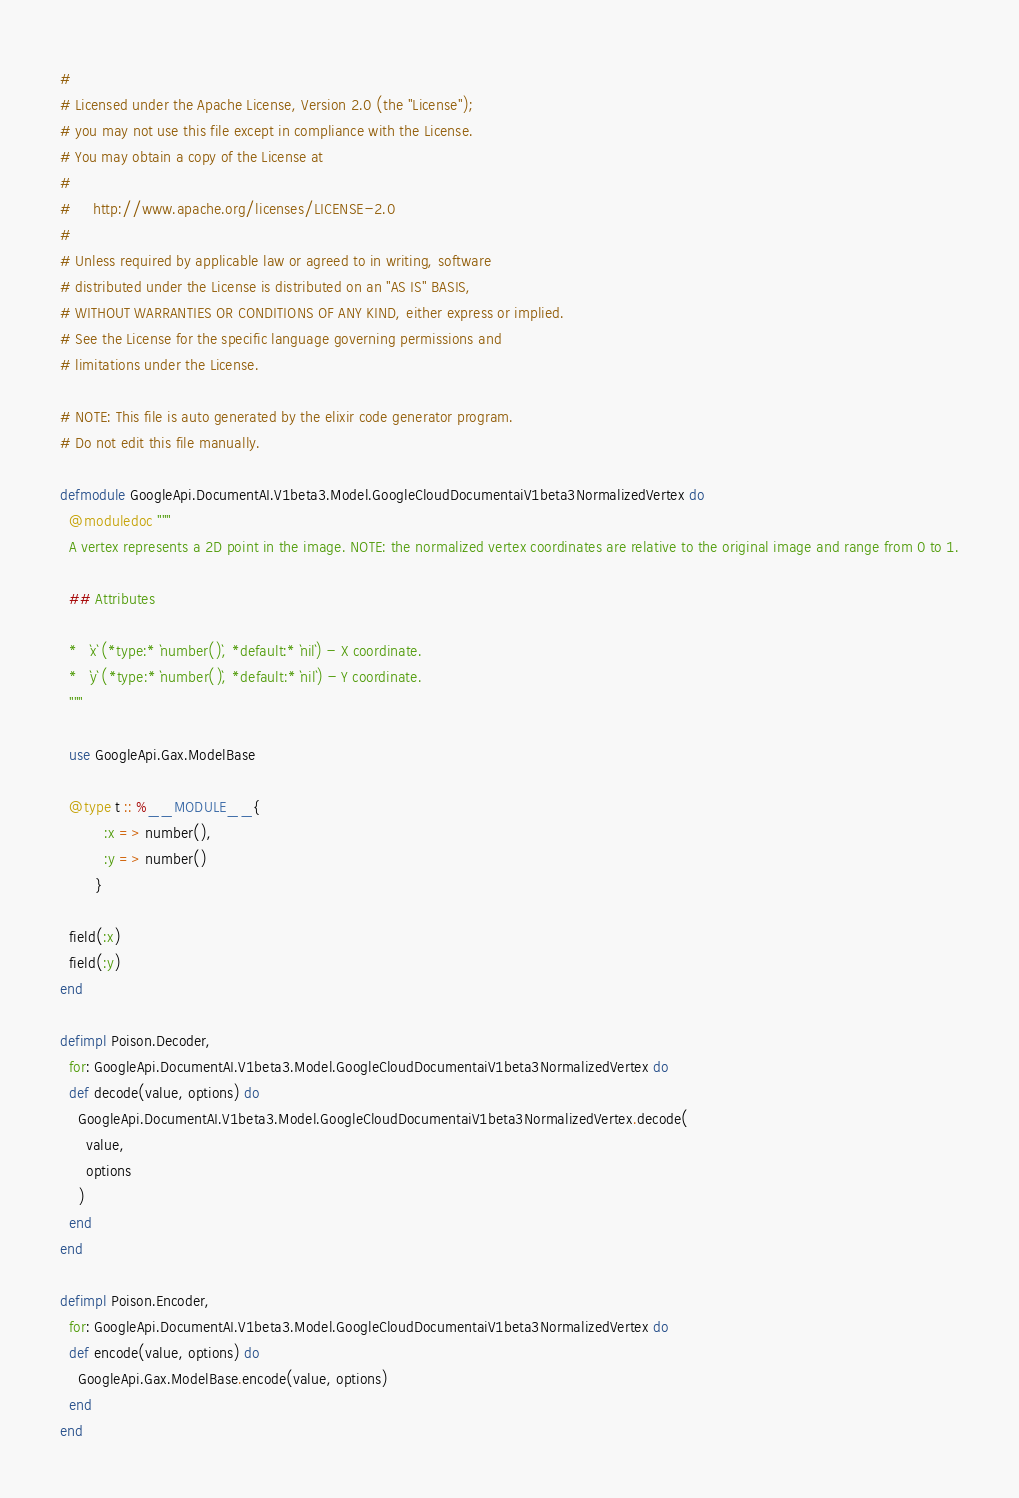Convert code to text. <code><loc_0><loc_0><loc_500><loc_500><_Elixir_>#
# Licensed under the Apache License, Version 2.0 (the "License");
# you may not use this file except in compliance with the License.
# You may obtain a copy of the License at
#
#     http://www.apache.org/licenses/LICENSE-2.0
#
# Unless required by applicable law or agreed to in writing, software
# distributed under the License is distributed on an "AS IS" BASIS,
# WITHOUT WARRANTIES OR CONDITIONS OF ANY KIND, either express or implied.
# See the License for the specific language governing permissions and
# limitations under the License.

# NOTE: This file is auto generated by the elixir code generator program.
# Do not edit this file manually.

defmodule GoogleApi.DocumentAI.V1beta3.Model.GoogleCloudDocumentaiV1beta3NormalizedVertex do
  @moduledoc """
  A vertex represents a 2D point in the image. NOTE: the normalized vertex coordinates are relative to the original image and range from 0 to 1.

  ## Attributes

  *   `x` (*type:* `number()`, *default:* `nil`) - X coordinate.
  *   `y` (*type:* `number()`, *default:* `nil`) - Y coordinate.
  """

  use GoogleApi.Gax.ModelBase

  @type t :: %__MODULE__{
          :x => number(),
          :y => number()
        }

  field(:x)
  field(:y)
end

defimpl Poison.Decoder,
  for: GoogleApi.DocumentAI.V1beta3.Model.GoogleCloudDocumentaiV1beta3NormalizedVertex do
  def decode(value, options) do
    GoogleApi.DocumentAI.V1beta3.Model.GoogleCloudDocumentaiV1beta3NormalizedVertex.decode(
      value,
      options
    )
  end
end

defimpl Poison.Encoder,
  for: GoogleApi.DocumentAI.V1beta3.Model.GoogleCloudDocumentaiV1beta3NormalizedVertex do
  def encode(value, options) do
    GoogleApi.Gax.ModelBase.encode(value, options)
  end
end
</code> 